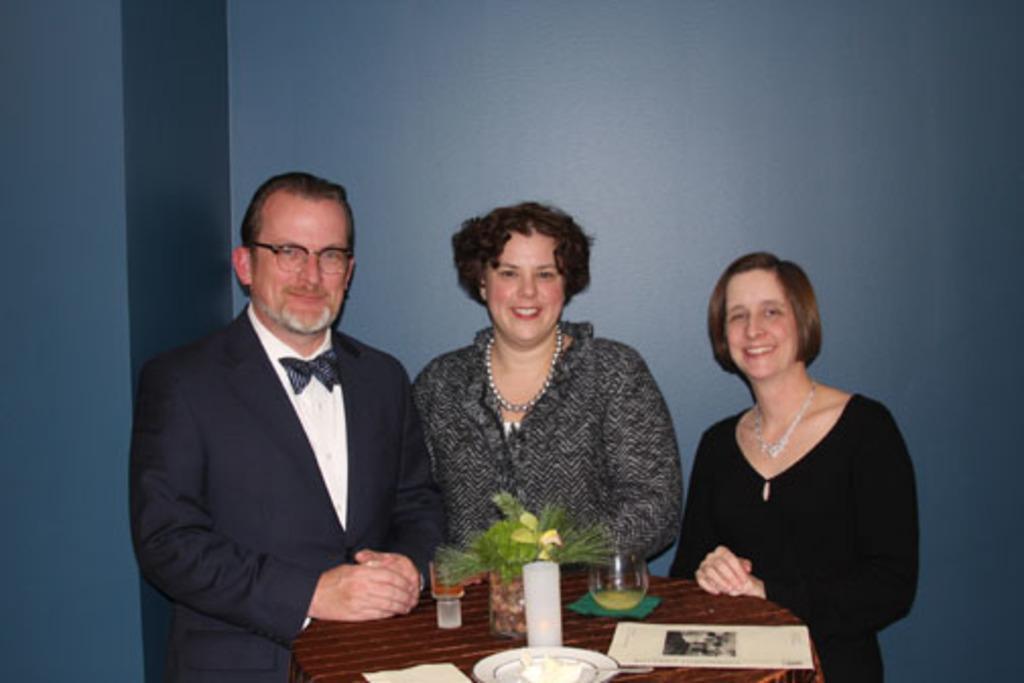Could you give a brief overview of what you see in this image? As we can see in the image there is a table. On table there is a candle, glass and paper and there are three persons. Behind these three persons there is a blue color wall. 